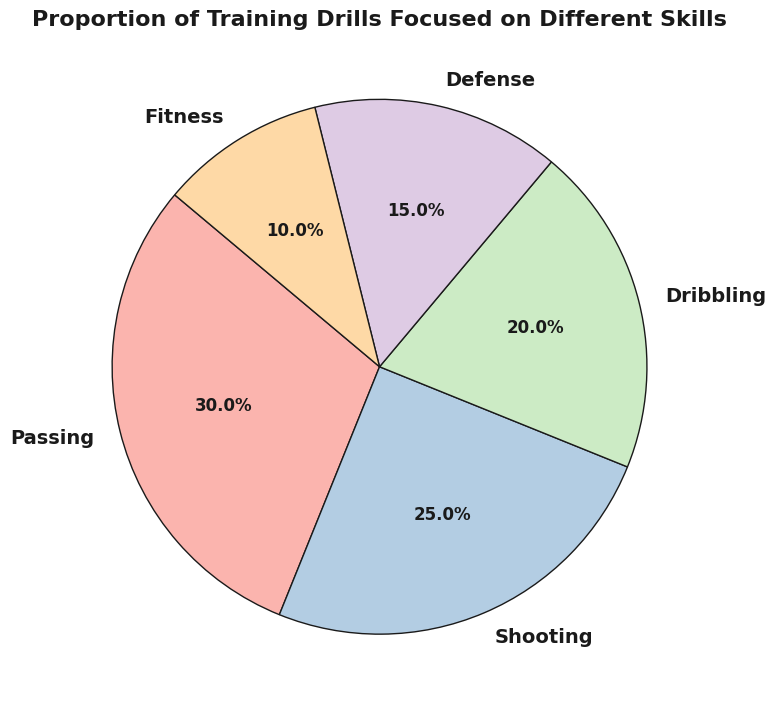Which skill has the highest proportion of training drills? To determine which skill has the highest proportion, look for the largest segment in the pie chart. The biggest segment corresponds to Passing with a proportion of 30%.
Answer: Passing What is the combined proportion of shooting and dribbling drills? To find the combined proportion, add the proportions of Shooting and Dribbling. Shooting has 25% and Dribbling has 20%, so the total is 25% + 20% = 45%.
Answer: 45% Which skill is focused on the least in training drills? The smallest segment in the pie chart represents the least focused skill. Fitness has the smallest proportion at 10%.
Answer: Fitness How much more focus is placed on passing drills than on defense drills? The proportion of Passing drills is 30%, and the proportion of Defense drills is 15%. Subtract the smaller proportion from the larger proportion: 30% - 15% = 15%.
Answer: 15% What proportion of training drills is dedicated to skills other than shooting? To find this, subtract the proportion of Shooting from the total 100%. Shooting is 25%, so the calculation is 100% - 25% = 75%.
Answer: 75% What is the average proportion of training drills dedicated to dribbling and fitness? Add the proportions of Dribbling (20%) and Fitness (10%), then divide by 2 to get the average: (20% + 10%) / 2 = 15%.
Answer: 15% Is the proportion of passing drills greater than the combined proportion of defense and fitness drills? First, add the proportions of Defense (15%) and Fitness (10%), which gives 25%. Passing is 30%, which is greater than 25%.
Answer: Yes What proportion of drills focuses on offensive skills (passing, shooting, dribbling)? Sum the proportions of Passing (30%), Shooting (25%), and Dribbling (20%): 30% + 25% + 20% = 75%.
Answer: 75% If 5 more percentage points were allocated to fitness, how much would fitness make up then? Fitness currently has 10%. Adding 5% means it will be 10% + 5% = 15%.
Answer: 15% How many skills have a higher proportion than fitness drills? Compare the proportion of each skill to that of Fitness (10%). Passing (30%), Shooting (25%), Dribbling (20%), and Defense (15%) are all higher than Fitness. There are 4 skills.
Answer: 4 